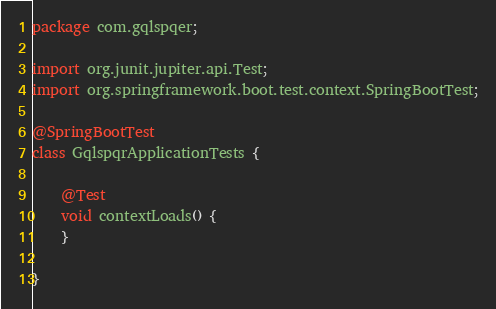Convert code to text. <code><loc_0><loc_0><loc_500><loc_500><_Java_>package com.gqlspqer;

import org.junit.jupiter.api.Test;
import org.springframework.boot.test.context.SpringBootTest;

@SpringBootTest
class GqlspqrApplicationTests {

	@Test
	void contextLoads() {
	}

}
</code> 